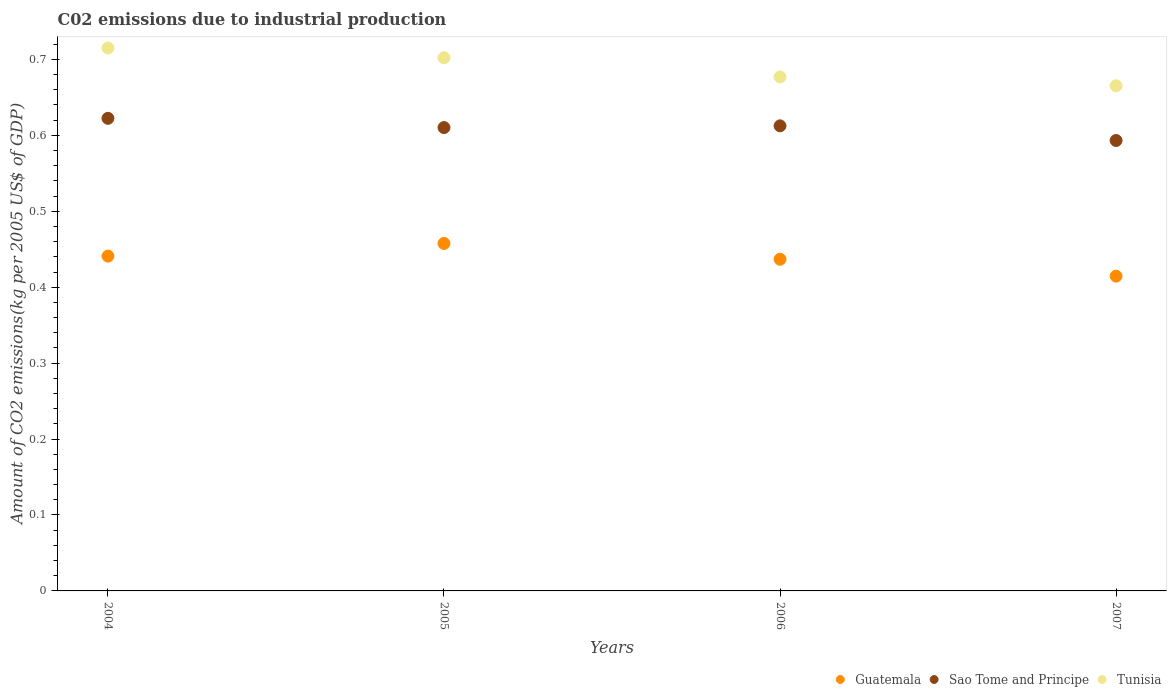Is the number of dotlines equal to the number of legend labels?
Ensure brevity in your answer.  Yes. What is the amount of CO2 emitted due to industrial production in Tunisia in 2007?
Provide a succinct answer. 0.67. Across all years, what is the maximum amount of CO2 emitted due to industrial production in Guatemala?
Ensure brevity in your answer.  0.46. Across all years, what is the minimum amount of CO2 emitted due to industrial production in Sao Tome and Principe?
Your answer should be very brief. 0.59. In which year was the amount of CO2 emitted due to industrial production in Sao Tome and Principe maximum?
Your answer should be very brief. 2004. In which year was the amount of CO2 emitted due to industrial production in Tunisia minimum?
Provide a short and direct response. 2007. What is the total amount of CO2 emitted due to industrial production in Sao Tome and Principe in the graph?
Keep it short and to the point. 2.44. What is the difference between the amount of CO2 emitted due to industrial production in Sao Tome and Principe in 2005 and that in 2006?
Keep it short and to the point. -0. What is the difference between the amount of CO2 emitted due to industrial production in Guatemala in 2005 and the amount of CO2 emitted due to industrial production in Sao Tome and Principe in 2007?
Your response must be concise. -0.14. What is the average amount of CO2 emitted due to industrial production in Sao Tome and Principe per year?
Provide a short and direct response. 0.61. In the year 2007, what is the difference between the amount of CO2 emitted due to industrial production in Sao Tome and Principe and amount of CO2 emitted due to industrial production in Guatemala?
Provide a short and direct response. 0.18. In how many years, is the amount of CO2 emitted due to industrial production in Tunisia greater than 0.6400000000000001 kg?
Offer a terse response. 4. What is the ratio of the amount of CO2 emitted due to industrial production in Tunisia in 2006 to that in 2007?
Your answer should be very brief. 1.02. Is the difference between the amount of CO2 emitted due to industrial production in Sao Tome and Principe in 2005 and 2006 greater than the difference between the amount of CO2 emitted due to industrial production in Guatemala in 2005 and 2006?
Give a very brief answer. No. What is the difference between the highest and the second highest amount of CO2 emitted due to industrial production in Guatemala?
Your answer should be compact. 0.02. What is the difference between the highest and the lowest amount of CO2 emitted due to industrial production in Tunisia?
Give a very brief answer. 0.05. Is the amount of CO2 emitted due to industrial production in Tunisia strictly less than the amount of CO2 emitted due to industrial production in Guatemala over the years?
Keep it short and to the point. No. How many dotlines are there?
Give a very brief answer. 3. How many years are there in the graph?
Your response must be concise. 4. Does the graph contain any zero values?
Give a very brief answer. No. How are the legend labels stacked?
Offer a terse response. Horizontal. What is the title of the graph?
Your answer should be compact. C02 emissions due to industrial production. Does "Guatemala" appear as one of the legend labels in the graph?
Your answer should be compact. Yes. What is the label or title of the X-axis?
Your response must be concise. Years. What is the label or title of the Y-axis?
Give a very brief answer. Amount of CO2 emissions(kg per 2005 US$ of GDP). What is the Amount of CO2 emissions(kg per 2005 US$ of GDP) of Guatemala in 2004?
Your response must be concise. 0.44. What is the Amount of CO2 emissions(kg per 2005 US$ of GDP) in Sao Tome and Principe in 2004?
Make the answer very short. 0.62. What is the Amount of CO2 emissions(kg per 2005 US$ of GDP) in Tunisia in 2004?
Ensure brevity in your answer.  0.72. What is the Amount of CO2 emissions(kg per 2005 US$ of GDP) in Guatemala in 2005?
Your response must be concise. 0.46. What is the Amount of CO2 emissions(kg per 2005 US$ of GDP) in Sao Tome and Principe in 2005?
Ensure brevity in your answer.  0.61. What is the Amount of CO2 emissions(kg per 2005 US$ of GDP) of Tunisia in 2005?
Offer a terse response. 0.7. What is the Amount of CO2 emissions(kg per 2005 US$ of GDP) of Guatemala in 2006?
Your response must be concise. 0.44. What is the Amount of CO2 emissions(kg per 2005 US$ of GDP) of Sao Tome and Principe in 2006?
Your response must be concise. 0.61. What is the Amount of CO2 emissions(kg per 2005 US$ of GDP) in Tunisia in 2006?
Make the answer very short. 0.68. What is the Amount of CO2 emissions(kg per 2005 US$ of GDP) in Guatemala in 2007?
Offer a terse response. 0.41. What is the Amount of CO2 emissions(kg per 2005 US$ of GDP) in Sao Tome and Principe in 2007?
Ensure brevity in your answer.  0.59. What is the Amount of CO2 emissions(kg per 2005 US$ of GDP) of Tunisia in 2007?
Give a very brief answer. 0.67. Across all years, what is the maximum Amount of CO2 emissions(kg per 2005 US$ of GDP) of Guatemala?
Provide a succinct answer. 0.46. Across all years, what is the maximum Amount of CO2 emissions(kg per 2005 US$ of GDP) in Sao Tome and Principe?
Provide a short and direct response. 0.62. Across all years, what is the maximum Amount of CO2 emissions(kg per 2005 US$ of GDP) in Tunisia?
Ensure brevity in your answer.  0.72. Across all years, what is the minimum Amount of CO2 emissions(kg per 2005 US$ of GDP) of Guatemala?
Your answer should be very brief. 0.41. Across all years, what is the minimum Amount of CO2 emissions(kg per 2005 US$ of GDP) in Sao Tome and Principe?
Your response must be concise. 0.59. Across all years, what is the minimum Amount of CO2 emissions(kg per 2005 US$ of GDP) of Tunisia?
Make the answer very short. 0.67. What is the total Amount of CO2 emissions(kg per 2005 US$ of GDP) in Guatemala in the graph?
Provide a succinct answer. 1.75. What is the total Amount of CO2 emissions(kg per 2005 US$ of GDP) in Sao Tome and Principe in the graph?
Your answer should be compact. 2.44. What is the total Amount of CO2 emissions(kg per 2005 US$ of GDP) of Tunisia in the graph?
Keep it short and to the point. 2.76. What is the difference between the Amount of CO2 emissions(kg per 2005 US$ of GDP) in Guatemala in 2004 and that in 2005?
Ensure brevity in your answer.  -0.02. What is the difference between the Amount of CO2 emissions(kg per 2005 US$ of GDP) in Sao Tome and Principe in 2004 and that in 2005?
Your response must be concise. 0.01. What is the difference between the Amount of CO2 emissions(kg per 2005 US$ of GDP) of Tunisia in 2004 and that in 2005?
Ensure brevity in your answer.  0.01. What is the difference between the Amount of CO2 emissions(kg per 2005 US$ of GDP) in Guatemala in 2004 and that in 2006?
Ensure brevity in your answer.  0. What is the difference between the Amount of CO2 emissions(kg per 2005 US$ of GDP) in Sao Tome and Principe in 2004 and that in 2006?
Your answer should be very brief. 0.01. What is the difference between the Amount of CO2 emissions(kg per 2005 US$ of GDP) in Tunisia in 2004 and that in 2006?
Offer a terse response. 0.04. What is the difference between the Amount of CO2 emissions(kg per 2005 US$ of GDP) of Guatemala in 2004 and that in 2007?
Offer a terse response. 0.03. What is the difference between the Amount of CO2 emissions(kg per 2005 US$ of GDP) in Sao Tome and Principe in 2004 and that in 2007?
Give a very brief answer. 0.03. What is the difference between the Amount of CO2 emissions(kg per 2005 US$ of GDP) of Tunisia in 2004 and that in 2007?
Offer a very short reply. 0.05. What is the difference between the Amount of CO2 emissions(kg per 2005 US$ of GDP) of Guatemala in 2005 and that in 2006?
Give a very brief answer. 0.02. What is the difference between the Amount of CO2 emissions(kg per 2005 US$ of GDP) in Sao Tome and Principe in 2005 and that in 2006?
Your response must be concise. -0. What is the difference between the Amount of CO2 emissions(kg per 2005 US$ of GDP) in Tunisia in 2005 and that in 2006?
Provide a succinct answer. 0.03. What is the difference between the Amount of CO2 emissions(kg per 2005 US$ of GDP) in Guatemala in 2005 and that in 2007?
Give a very brief answer. 0.04. What is the difference between the Amount of CO2 emissions(kg per 2005 US$ of GDP) of Sao Tome and Principe in 2005 and that in 2007?
Provide a succinct answer. 0.02. What is the difference between the Amount of CO2 emissions(kg per 2005 US$ of GDP) of Tunisia in 2005 and that in 2007?
Keep it short and to the point. 0.04. What is the difference between the Amount of CO2 emissions(kg per 2005 US$ of GDP) of Guatemala in 2006 and that in 2007?
Give a very brief answer. 0.02. What is the difference between the Amount of CO2 emissions(kg per 2005 US$ of GDP) of Sao Tome and Principe in 2006 and that in 2007?
Offer a very short reply. 0.02. What is the difference between the Amount of CO2 emissions(kg per 2005 US$ of GDP) of Tunisia in 2006 and that in 2007?
Give a very brief answer. 0.01. What is the difference between the Amount of CO2 emissions(kg per 2005 US$ of GDP) in Guatemala in 2004 and the Amount of CO2 emissions(kg per 2005 US$ of GDP) in Sao Tome and Principe in 2005?
Provide a succinct answer. -0.17. What is the difference between the Amount of CO2 emissions(kg per 2005 US$ of GDP) in Guatemala in 2004 and the Amount of CO2 emissions(kg per 2005 US$ of GDP) in Tunisia in 2005?
Ensure brevity in your answer.  -0.26. What is the difference between the Amount of CO2 emissions(kg per 2005 US$ of GDP) in Sao Tome and Principe in 2004 and the Amount of CO2 emissions(kg per 2005 US$ of GDP) in Tunisia in 2005?
Give a very brief answer. -0.08. What is the difference between the Amount of CO2 emissions(kg per 2005 US$ of GDP) in Guatemala in 2004 and the Amount of CO2 emissions(kg per 2005 US$ of GDP) in Sao Tome and Principe in 2006?
Keep it short and to the point. -0.17. What is the difference between the Amount of CO2 emissions(kg per 2005 US$ of GDP) of Guatemala in 2004 and the Amount of CO2 emissions(kg per 2005 US$ of GDP) of Tunisia in 2006?
Your answer should be compact. -0.24. What is the difference between the Amount of CO2 emissions(kg per 2005 US$ of GDP) in Sao Tome and Principe in 2004 and the Amount of CO2 emissions(kg per 2005 US$ of GDP) in Tunisia in 2006?
Give a very brief answer. -0.05. What is the difference between the Amount of CO2 emissions(kg per 2005 US$ of GDP) of Guatemala in 2004 and the Amount of CO2 emissions(kg per 2005 US$ of GDP) of Sao Tome and Principe in 2007?
Ensure brevity in your answer.  -0.15. What is the difference between the Amount of CO2 emissions(kg per 2005 US$ of GDP) of Guatemala in 2004 and the Amount of CO2 emissions(kg per 2005 US$ of GDP) of Tunisia in 2007?
Provide a succinct answer. -0.22. What is the difference between the Amount of CO2 emissions(kg per 2005 US$ of GDP) in Sao Tome and Principe in 2004 and the Amount of CO2 emissions(kg per 2005 US$ of GDP) in Tunisia in 2007?
Keep it short and to the point. -0.04. What is the difference between the Amount of CO2 emissions(kg per 2005 US$ of GDP) in Guatemala in 2005 and the Amount of CO2 emissions(kg per 2005 US$ of GDP) in Sao Tome and Principe in 2006?
Keep it short and to the point. -0.15. What is the difference between the Amount of CO2 emissions(kg per 2005 US$ of GDP) of Guatemala in 2005 and the Amount of CO2 emissions(kg per 2005 US$ of GDP) of Tunisia in 2006?
Keep it short and to the point. -0.22. What is the difference between the Amount of CO2 emissions(kg per 2005 US$ of GDP) in Sao Tome and Principe in 2005 and the Amount of CO2 emissions(kg per 2005 US$ of GDP) in Tunisia in 2006?
Ensure brevity in your answer.  -0.07. What is the difference between the Amount of CO2 emissions(kg per 2005 US$ of GDP) in Guatemala in 2005 and the Amount of CO2 emissions(kg per 2005 US$ of GDP) in Sao Tome and Principe in 2007?
Provide a short and direct response. -0.14. What is the difference between the Amount of CO2 emissions(kg per 2005 US$ of GDP) of Guatemala in 2005 and the Amount of CO2 emissions(kg per 2005 US$ of GDP) of Tunisia in 2007?
Make the answer very short. -0.21. What is the difference between the Amount of CO2 emissions(kg per 2005 US$ of GDP) of Sao Tome and Principe in 2005 and the Amount of CO2 emissions(kg per 2005 US$ of GDP) of Tunisia in 2007?
Your answer should be very brief. -0.06. What is the difference between the Amount of CO2 emissions(kg per 2005 US$ of GDP) in Guatemala in 2006 and the Amount of CO2 emissions(kg per 2005 US$ of GDP) in Sao Tome and Principe in 2007?
Make the answer very short. -0.16. What is the difference between the Amount of CO2 emissions(kg per 2005 US$ of GDP) of Guatemala in 2006 and the Amount of CO2 emissions(kg per 2005 US$ of GDP) of Tunisia in 2007?
Your answer should be very brief. -0.23. What is the difference between the Amount of CO2 emissions(kg per 2005 US$ of GDP) in Sao Tome and Principe in 2006 and the Amount of CO2 emissions(kg per 2005 US$ of GDP) in Tunisia in 2007?
Give a very brief answer. -0.05. What is the average Amount of CO2 emissions(kg per 2005 US$ of GDP) of Guatemala per year?
Provide a short and direct response. 0.44. What is the average Amount of CO2 emissions(kg per 2005 US$ of GDP) of Sao Tome and Principe per year?
Give a very brief answer. 0.61. What is the average Amount of CO2 emissions(kg per 2005 US$ of GDP) of Tunisia per year?
Provide a succinct answer. 0.69. In the year 2004, what is the difference between the Amount of CO2 emissions(kg per 2005 US$ of GDP) in Guatemala and Amount of CO2 emissions(kg per 2005 US$ of GDP) in Sao Tome and Principe?
Your answer should be compact. -0.18. In the year 2004, what is the difference between the Amount of CO2 emissions(kg per 2005 US$ of GDP) in Guatemala and Amount of CO2 emissions(kg per 2005 US$ of GDP) in Tunisia?
Offer a very short reply. -0.27. In the year 2004, what is the difference between the Amount of CO2 emissions(kg per 2005 US$ of GDP) of Sao Tome and Principe and Amount of CO2 emissions(kg per 2005 US$ of GDP) of Tunisia?
Your answer should be very brief. -0.09. In the year 2005, what is the difference between the Amount of CO2 emissions(kg per 2005 US$ of GDP) of Guatemala and Amount of CO2 emissions(kg per 2005 US$ of GDP) of Sao Tome and Principe?
Your response must be concise. -0.15. In the year 2005, what is the difference between the Amount of CO2 emissions(kg per 2005 US$ of GDP) in Guatemala and Amount of CO2 emissions(kg per 2005 US$ of GDP) in Tunisia?
Provide a succinct answer. -0.24. In the year 2005, what is the difference between the Amount of CO2 emissions(kg per 2005 US$ of GDP) in Sao Tome and Principe and Amount of CO2 emissions(kg per 2005 US$ of GDP) in Tunisia?
Give a very brief answer. -0.09. In the year 2006, what is the difference between the Amount of CO2 emissions(kg per 2005 US$ of GDP) of Guatemala and Amount of CO2 emissions(kg per 2005 US$ of GDP) of Sao Tome and Principe?
Offer a very short reply. -0.18. In the year 2006, what is the difference between the Amount of CO2 emissions(kg per 2005 US$ of GDP) of Guatemala and Amount of CO2 emissions(kg per 2005 US$ of GDP) of Tunisia?
Make the answer very short. -0.24. In the year 2006, what is the difference between the Amount of CO2 emissions(kg per 2005 US$ of GDP) of Sao Tome and Principe and Amount of CO2 emissions(kg per 2005 US$ of GDP) of Tunisia?
Your answer should be very brief. -0.06. In the year 2007, what is the difference between the Amount of CO2 emissions(kg per 2005 US$ of GDP) in Guatemala and Amount of CO2 emissions(kg per 2005 US$ of GDP) in Sao Tome and Principe?
Your answer should be compact. -0.18. In the year 2007, what is the difference between the Amount of CO2 emissions(kg per 2005 US$ of GDP) of Guatemala and Amount of CO2 emissions(kg per 2005 US$ of GDP) of Tunisia?
Your answer should be very brief. -0.25. In the year 2007, what is the difference between the Amount of CO2 emissions(kg per 2005 US$ of GDP) of Sao Tome and Principe and Amount of CO2 emissions(kg per 2005 US$ of GDP) of Tunisia?
Your response must be concise. -0.07. What is the ratio of the Amount of CO2 emissions(kg per 2005 US$ of GDP) in Guatemala in 2004 to that in 2005?
Offer a very short reply. 0.96. What is the ratio of the Amount of CO2 emissions(kg per 2005 US$ of GDP) in Sao Tome and Principe in 2004 to that in 2005?
Provide a succinct answer. 1.02. What is the ratio of the Amount of CO2 emissions(kg per 2005 US$ of GDP) in Tunisia in 2004 to that in 2005?
Your answer should be compact. 1.02. What is the ratio of the Amount of CO2 emissions(kg per 2005 US$ of GDP) in Guatemala in 2004 to that in 2006?
Provide a succinct answer. 1.01. What is the ratio of the Amount of CO2 emissions(kg per 2005 US$ of GDP) of Sao Tome and Principe in 2004 to that in 2006?
Ensure brevity in your answer.  1.02. What is the ratio of the Amount of CO2 emissions(kg per 2005 US$ of GDP) of Tunisia in 2004 to that in 2006?
Ensure brevity in your answer.  1.06. What is the ratio of the Amount of CO2 emissions(kg per 2005 US$ of GDP) of Guatemala in 2004 to that in 2007?
Provide a short and direct response. 1.06. What is the ratio of the Amount of CO2 emissions(kg per 2005 US$ of GDP) in Sao Tome and Principe in 2004 to that in 2007?
Give a very brief answer. 1.05. What is the ratio of the Amount of CO2 emissions(kg per 2005 US$ of GDP) of Tunisia in 2004 to that in 2007?
Offer a terse response. 1.07. What is the ratio of the Amount of CO2 emissions(kg per 2005 US$ of GDP) of Guatemala in 2005 to that in 2006?
Provide a short and direct response. 1.05. What is the ratio of the Amount of CO2 emissions(kg per 2005 US$ of GDP) in Sao Tome and Principe in 2005 to that in 2006?
Your answer should be compact. 1. What is the ratio of the Amount of CO2 emissions(kg per 2005 US$ of GDP) in Tunisia in 2005 to that in 2006?
Offer a very short reply. 1.04. What is the ratio of the Amount of CO2 emissions(kg per 2005 US$ of GDP) of Guatemala in 2005 to that in 2007?
Offer a very short reply. 1.1. What is the ratio of the Amount of CO2 emissions(kg per 2005 US$ of GDP) of Sao Tome and Principe in 2005 to that in 2007?
Your answer should be very brief. 1.03. What is the ratio of the Amount of CO2 emissions(kg per 2005 US$ of GDP) of Tunisia in 2005 to that in 2007?
Your response must be concise. 1.06. What is the ratio of the Amount of CO2 emissions(kg per 2005 US$ of GDP) of Guatemala in 2006 to that in 2007?
Give a very brief answer. 1.05. What is the ratio of the Amount of CO2 emissions(kg per 2005 US$ of GDP) in Sao Tome and Principe in 2006 to that in 2007?
Make the answer very short. 1.03. What is the ratio of the Amount of CO2 emissions(kg per 2005 US$ of GDP) in Tunisia in 2006 to that in 2007?
Keep it short and to the point. 1.02. What is the difference between the highest and the second highest Amount of CO2 emissions(kg per 2005 US$ of GDP) in Guatemala?
Provide a succinct answer. 0.02. What is the difference between the highest and the second highest Amount of CO2 emissions(kg per 2005 US$ of GDP) of Sao Tome and Principe?
Keep it short and to the point. 0.01. What is the difference between the highest and the second highest Amount of CO2 emissions(kg per 2005 US$ of GDP) of Tunisia?
Your answer should be very brief. 0.01. What is the difference between the highest and the lowest Amount of CO2 emissions(kg per 2005 US$ of GDP) of Guatemala?
Ensure brevity in your answer.  0.04. What is the difference between the highest and the lowest Amount of CO2 emissions(kg per 2005 US$ of GDP) in Sao Tome and Principe?
Ensure brevity in your answer.  0.03. What is the difference between the highest and the lowest Amount of CO2 emissions(kg per 2005 US$ of GDP) in Tunisia?
Provide a succinct answer. 0.05. 